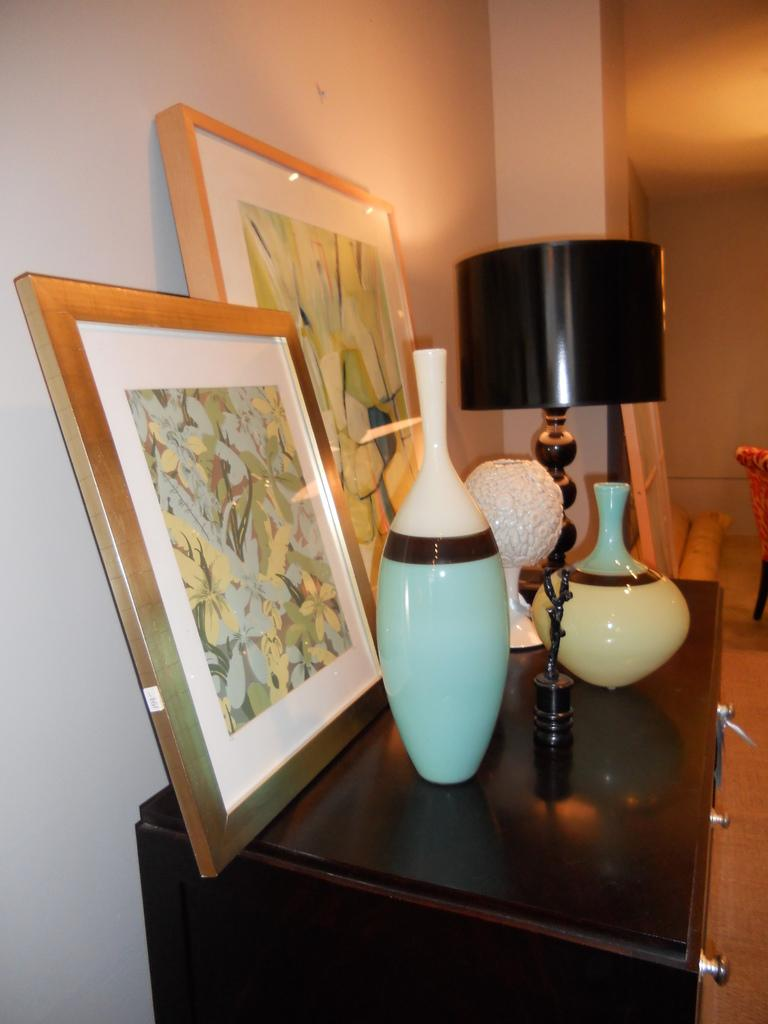What type of furniture is present in the image? There is a table in the image. What other object can be seen in the image that is used for storage? There is a shelf in the image. What is located on the shelf in the image? There is a flower pot in the image. What type of light source is visible in the image? There is a lamp in the image. What object is used for displaying a photo in the image? There is a photo frame in the image. What is the background of the image made of? The background of the image is a wall. What type of van is parked in front of the wall in the image? There is no van present in the image; the background is a wall. 